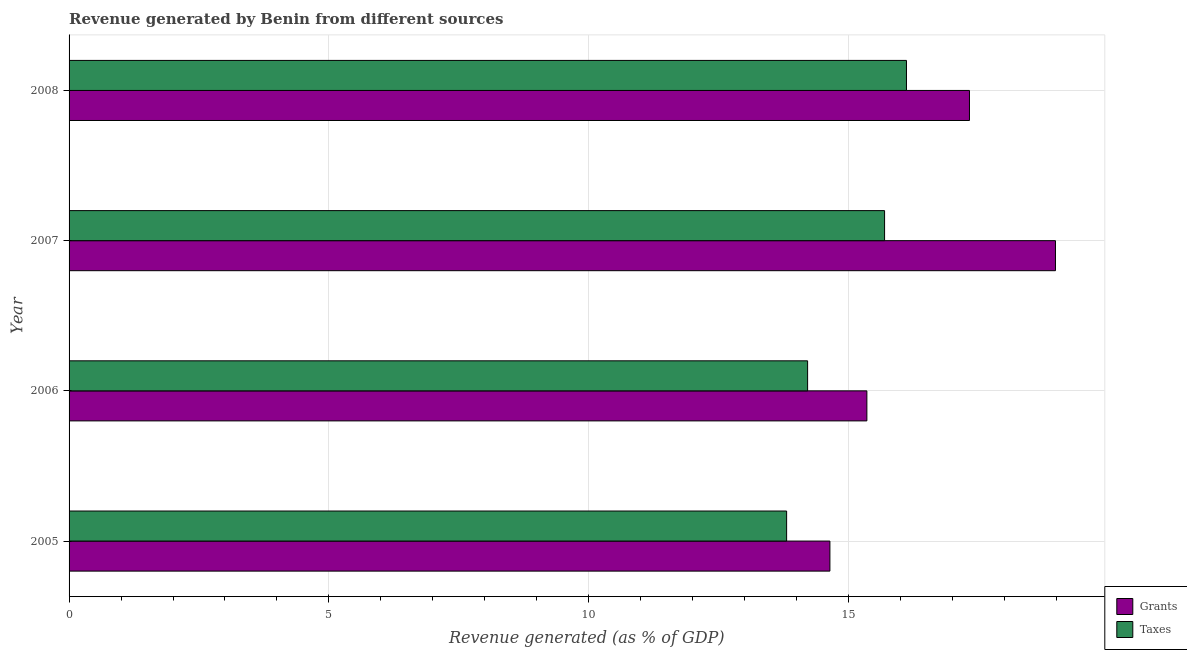How many different coloured bars are there?
Your response must be concise. 2. How many bars are there on the 4th tick from the top?
Provide a short and direct response. 2. How many bars are there on the 2nd tick from the bottom?
Your answer should be compact. 2. What is the revenue generated by grants in 2005?
Ensure brevity in your answer.  14.64. Across all years, what is the maximum revenue generated by grants?
Keep it short and to the point. 18.98. Across all years, what is the minimum revenue generated by taxes?
Make the answer very short. 13.81. In which year was the revenue generated by grants maximum?
Your answer should be compact. 2007. In which year was the revenue generated by grants minimum?
Give a very brief answer. 2005. What is the total revenue generated by taxes in the graph?
Give a very brief answer. 59.83. What is the difference between the revenue generated by grants in 2005 and that in 2006?
Offer a terse response. -0.71. What is the difference between the revenue generated by grants in 2008 and the revenue generated by taxes in 2007?
Your answer should be very brief. 1.63. What is the average revenue generated by grants per year?
Offer a terse response. 16.58. In the year 2005, what is the difference between the revenue generated by grants and revenue generated by taxes?
Make the answer very short. 0.83. In how many years, is the revenue generated by grants greater than 8 %?
Make the answer very short. 4. What is the ratio of the revenue generated by taxes in 2007 to that in 2008?
Give a very brief answer. 0.97. What is the difference between the highest and the second highest revenue generated by grants?
Keep it short and to the point. 1.66. What is the difference between the highest and the lowest revenue generated by grants?
Your answer should be very brief. 4.34. In how many years, is the revenue generated by taxes greater than the average revenue generated by taxes taken over all years?
Keep it short and to the point. 2. Is the sum of the revenue generated by grants in 2006 and 2007 greater than the maximum revenue generated by taxes across all years?
Offer a very short reply. Yes. What does the 1st bar from the top in 2006 represents?
Offer a terse response. Taxes. What does the 2nd bar from the bottom in 2008 represents?
Your response must be concise. Taxes. Are the values on the major ticks of X-axis written in scientific E-notation?
Offer a terse response. No. Does the graph contain grids?
Make the answer very short. Yes. What is the title of the graph?
Offer a very short reply. Revenue generated by Benin from different sources. Does "2012 US$" appear as one of the legend labels in the graph?
Your answer should be very brief. No. What is the label or title of the X-axis?
Your response must be concise. Revenue generated (as % of GDP). What is the Revenue generated (as % of GDP) in Grants in 2005?
Your response must be concise. 14.64. What is the Revenue generated (as % of GDP) of Taxes in 2005?
Offer a very short reply. 13.81. What is the Revenue generated (as % of GDP) of Grants in 2006?
Offer a very short reply. 15.35. What is the Revenue generated (as % of GDP) of Taxes in 2006?
Keep it short and to the point. 14.21. What is the Revenue generated (as % of GDP) in Grants in 2007?
Offer a very short reply. 18.98. What is the Revenue generated (as % of GDP) in Taxes in 2007?
Your response must be concise. 15.69. What is the Revenue generated (as % of GDP) of Grants in 2008?
Keep it short and to the point. 17.33. What is the Revenue generated (as % of GDP) in Taxes in 2008?
Make the answer very short. 16.12. Across all years, what is the maximum Revenue generated (as % of GDP) of Grants?
Provide a short and direct response. 18.98. Across all years, what is the maximum Revenue generated (as % of GDP) of Taxes?
Give a very brief answer. 16.12. Across all years, what is the minimum Revenue generated (as % of GDP) of Grants?
Offer a terse response. 14.64. Across all years, what is the minimum Revenue generated (as % of GDP) of Taxes?
Make the answer very short. 13.81. What is the total Revenue generated (as % of GDP) in Grants in the graph?
Your answer should be very brief. 66.31. What is the total Revenue generated (as % of GDP) of Taxes in the graph?
Ensure brevity in your answer.  59.83. What is the difference between the Revenue generated (as % of GDP) of Grants in 2005 and that in 2006?
Ensure brevity in your answer.  -0.71. What is the difference between the Revenue generated (as % of GDP) in Taxes in 2005 and that in 2006?
Keep it short and to the point. -0.4. What is the difference between the Revenue generated (as % of GDP) of Grants in 2005 and that in 2007?
Make the answer very short. -4.34. What is the difference between the Revenue generated (as % of GDP) in Taxes in 2005 and that in 2007?
Ensure brevity in your answer.  -1.89. What is the difference between the Revenue generated (as % of GDP) in Grants in 2005 and that in 2008?
Your response must be concise. -2.69. What is the difference between the Revenue generated (as % of GDP) of Taxes in 2005 and that in 2008?
Your response must be concise. -2.31. What is the difference between the Revenue generated (as % of GDP) in Grants in 2006 and that in 2007?
Offer a terse response. -3.63. What is the difference between the Revenue generated (as % of GDP) of Taxes in 2006 and that in 2007?
Offer a very short reply. -1.48. What is the difference between the Revenue generated (as % of GDP) of Grants in 2006 and that in 2008?
Keep it short and to the point. -1.97. What is the difference between the Revenue generated (as % of GDP) in Taxes in 2006 and that in 2008?
Provide a succinct answer. -1.9. What is the difference between the Revenue generated (as % of GDP) in Grants in 2007 and that in 2008?
Your response must be concise. 1.66. What is the difference between the Revenue generated (as % of GDP) in Taxes in 2007 and that in 2008?
Provide a short and direct response. -0.42. What is the difference between the Revenue generated (as % of GDP) of Grants in 2005 and the Revenue generated (as % of GDP) of Taxes in 2006?
Your answer should be very brief. 0.43. What is the difference between the Revenue generated (as % of GDP) of Grants in 2005 and the Revenue generated (as % of GDP) of Taxes in 2007?
Offer a terse response. -1.05. What is the difference between the Revenue generated (as % of GDP) in Grants in 2005 and the Revenue generated (as % of GDP) in Taxes in 2008?
Ensure brevity in your answer.  -1.47. What is the difference between the Revenue generated (as % of GDP) of Grants in 2006 and the Revenue generated (as % of GDP) of Taxes in 2007?
Provide a succinct answer. -0.34. What is the difference between the Revenue generated (as % of GDP) in Grants in 2006 and the Revenue generated (as % of GDP) in Taxes in 2008?
Your answer should be compact. -0.76. What is the difference between the Revenue generated (as % of GDP) of Grants in 2007 and the Revenue generated (as % of GDP) of Taxes in 2008?
Offer a terse response. 2.87. What is the average Revenue generated (as % of GDP) in Grants per year?
Provide a short and direct response. 16.58. What is the average Revenue generated (as % of GDP) of Taxes per year?
Your answer should be compact. 14.96. In the year 2005, what is the difference between the Revenue generated (as % of GDP) in Grants and Revenue generated (as % of GDP) in Taxes?
Offer a terse response. 0.83. In the year 2006, what is the difference between the Revenue generated (as % of GDP) of Grants and Revenue generated (as % of GDP) of Taxes?
Keep it short and to the point. 1.14. In the year 2007, what is the difference between the Revenue generated (as % of GDP) in Grants and Revenue generated (as % of GDP) in Taxes?
Your answer should be compact. 3.29. In the year 2008, what is the difference between the Revenue generated (as % of GDP) of Grants and Revenue generated (as % of GDP) of Taxes?
Offer a very short reply. 1.21. What is the ratio of the Revenue generated (as % of GDP) in Grants in 2005 to that in 2006?
Your answer should be compact. 0.95. What is the ratio of the Revenue generated (as % of GDP) of Taxes in 2005 to that in 2006?
Offer a very short reply. 0.97. What is the ratio of the Revenue generated (as % of GDP) of Grants in 2005 to that in 2007?
Offer a terse response. 0.77. What is the ratio of the Revenue generated (as % of GDP) in Taxes in 2005 to that in 2007?
Ensure brevity in your answer.  0.88. What is the ratio of the Revenue generated (as % of GDP) in Grants in 2005 to that in 2008?
Offer a terse response. 0.84. What is the ratio of the Revenue generated (as % of GDP) in Taxes in 2005 to that in 2008?
Provide a succinct answer. 0.86. What is the ratio of the Revenue generated (as % of GDP) of Grants in 2006 to that in 2007?
Offer a terse response. 0.81. What is the ratio of the Revenue generated (as % of GDP) of Taxes in 2006 to that in 2007?
Offer a very short reply. 0.91. What is the ratio of the Revenue generated (as % of GDP) in Grants in 2006 to that in 2008?
Give a very brief answer. 0.89. What is the ratio of the Revenue generated (as % of GDP) in Taxes in 2006 to that in 2008?
Your answer should be very brief. 0.88. What is the ratio of the Revenue generated (as % of GDP) of Grants in 2007 to that in 2008?
Offer a terse response. 1.1. What is the ratio of the Revenue generated (as % of GDP) of Taxes in 2007 to that in 2008?
Provide a succinct answer. 0.97. What is the difference between the highest and the second highest Revenue generated (as % of GDP) of Grants?
Offer a very short reply. 1.66. What is the difference between the highest and the second highest Revenue generated (as % of GDP) of Taxes?
Your answer should be compact. 0.42. What is the difference between the highest and the lowest Revenue generated (as % of GDP) in Grants?
Your response must be concise. 4.34. What is the difference between the highest and the lowest Revenue generated (as % of GDP) of Taxes?
Your answer should be compact. 2.31. 